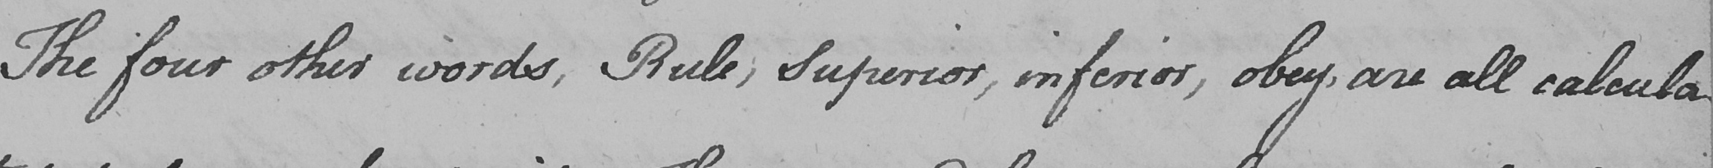What is written in this line of handwriting? The four other words , Rule , Superior , inferior , obey , are all calcula- 